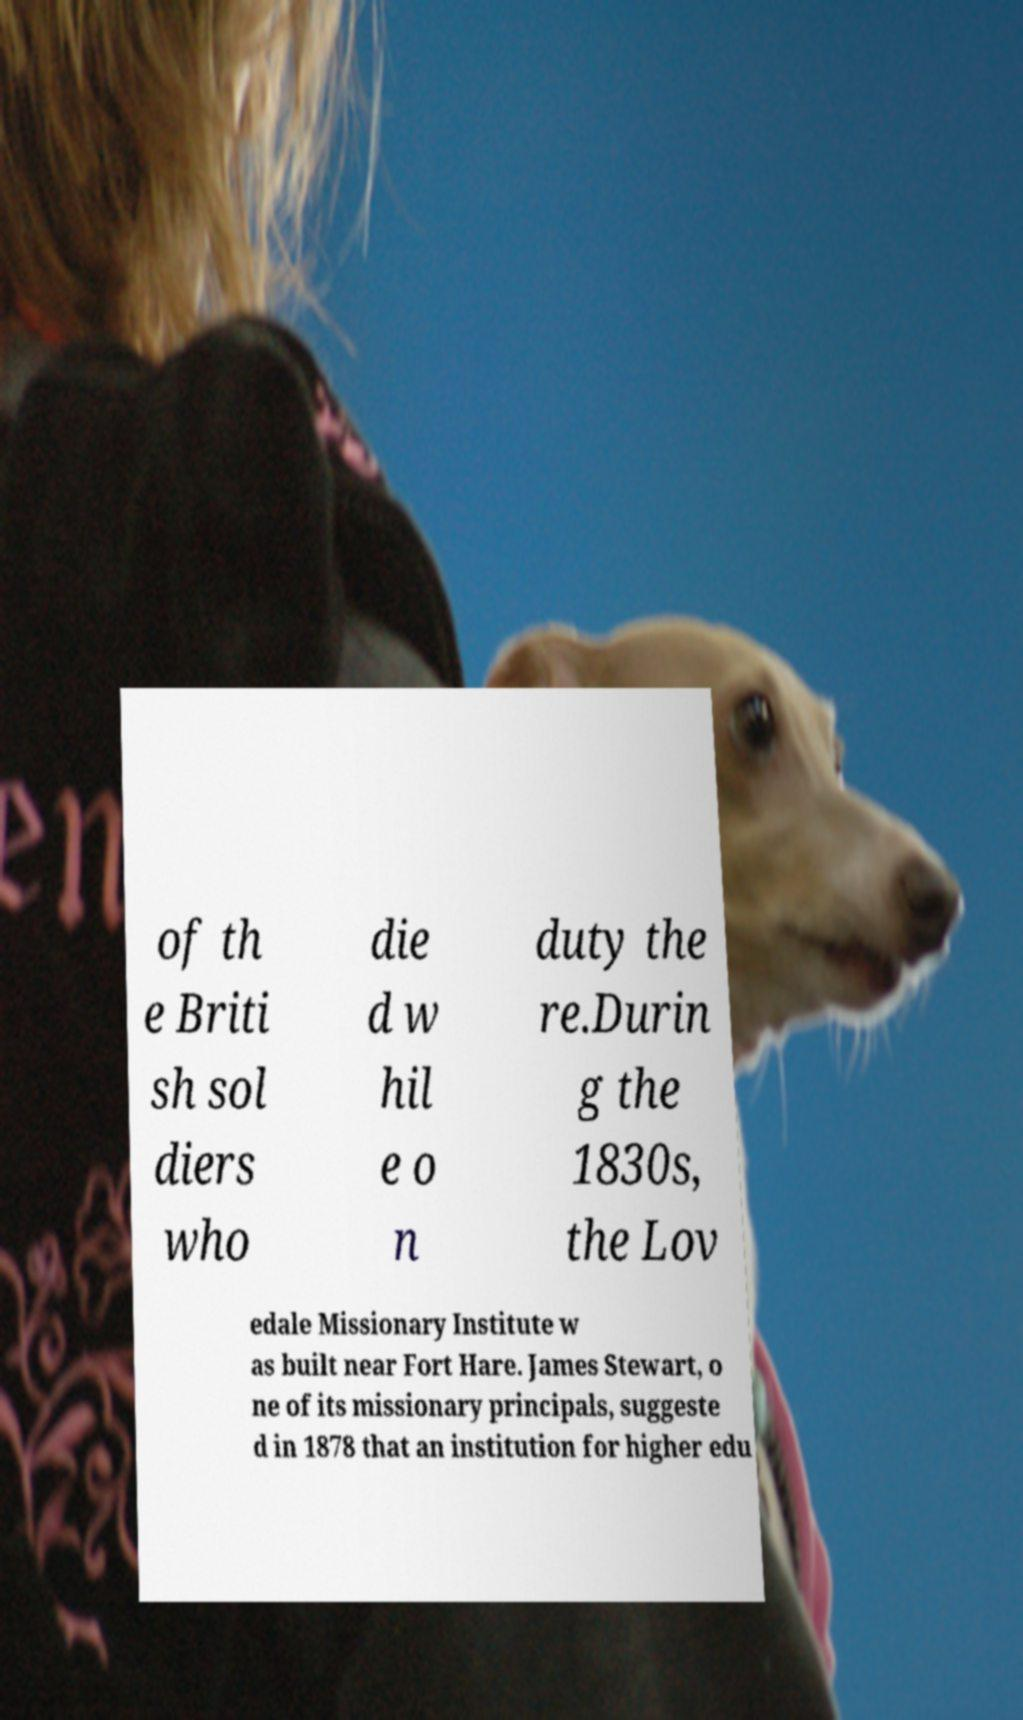Please read and relay the text visible in this image. What does it say? of th e Briti sh sol diers who die d w hil e o n duty the re.Durin g the 1830s, the Lov edale Missionary Institute w as built near Fort Hare. James Stewart, o ne of its missionary principals, suggeste d in 1878 that an institution for higher edu 